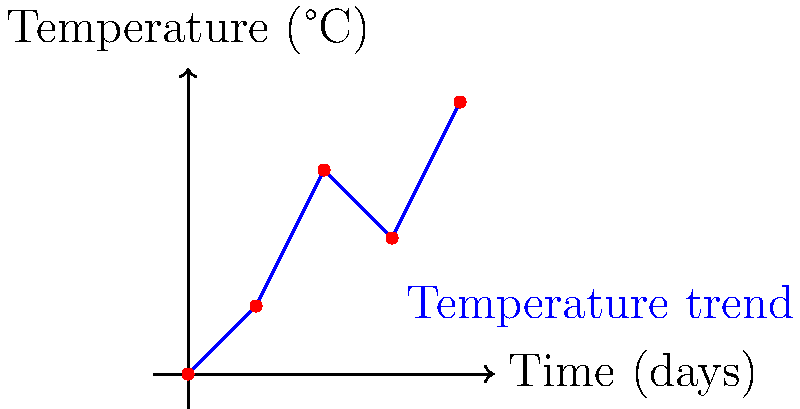Based on the weather satellite data shown in the graph, which day would be most suitable for applying pesticides to your crops? To determine the best day for pesticide application, we need to consider the temperature trend:

1. Day 0: Temperature starts at 0°C
2. Day 1: Temperature rises to 1°C
3. Day 2: Temperature increases to 3°C
4. Day 3: Temperature drops to 2°C
5. Day 4: Temperature rises again to 4°C

Pesticide application is generally most effective when:
a) Temperatures are moderate (not too hot or cold)
b) There's a stable or slightly rising temperature trend

Analyzing the data:
- Days 0 and 1 are too cold for effective pesticide application.
- Day 2 shows a sharp increase, which might be too warm and could cause the pesticide to evaporate quickly.
- Day 3 shows a temperature drop, which is not ideal for pesticide effectiveness.
- Day 4 is the warmest, which could lead to rapid evaporation of the pesticide.

The best choice would be Day 1 because:
1. The temperature is moderate (1°C)
2. It's at the beginning of a rising temperature trend
3. It allows time for the pesticide to be effective before the sharp temperature increase on Day 2
Answer: Day 1 